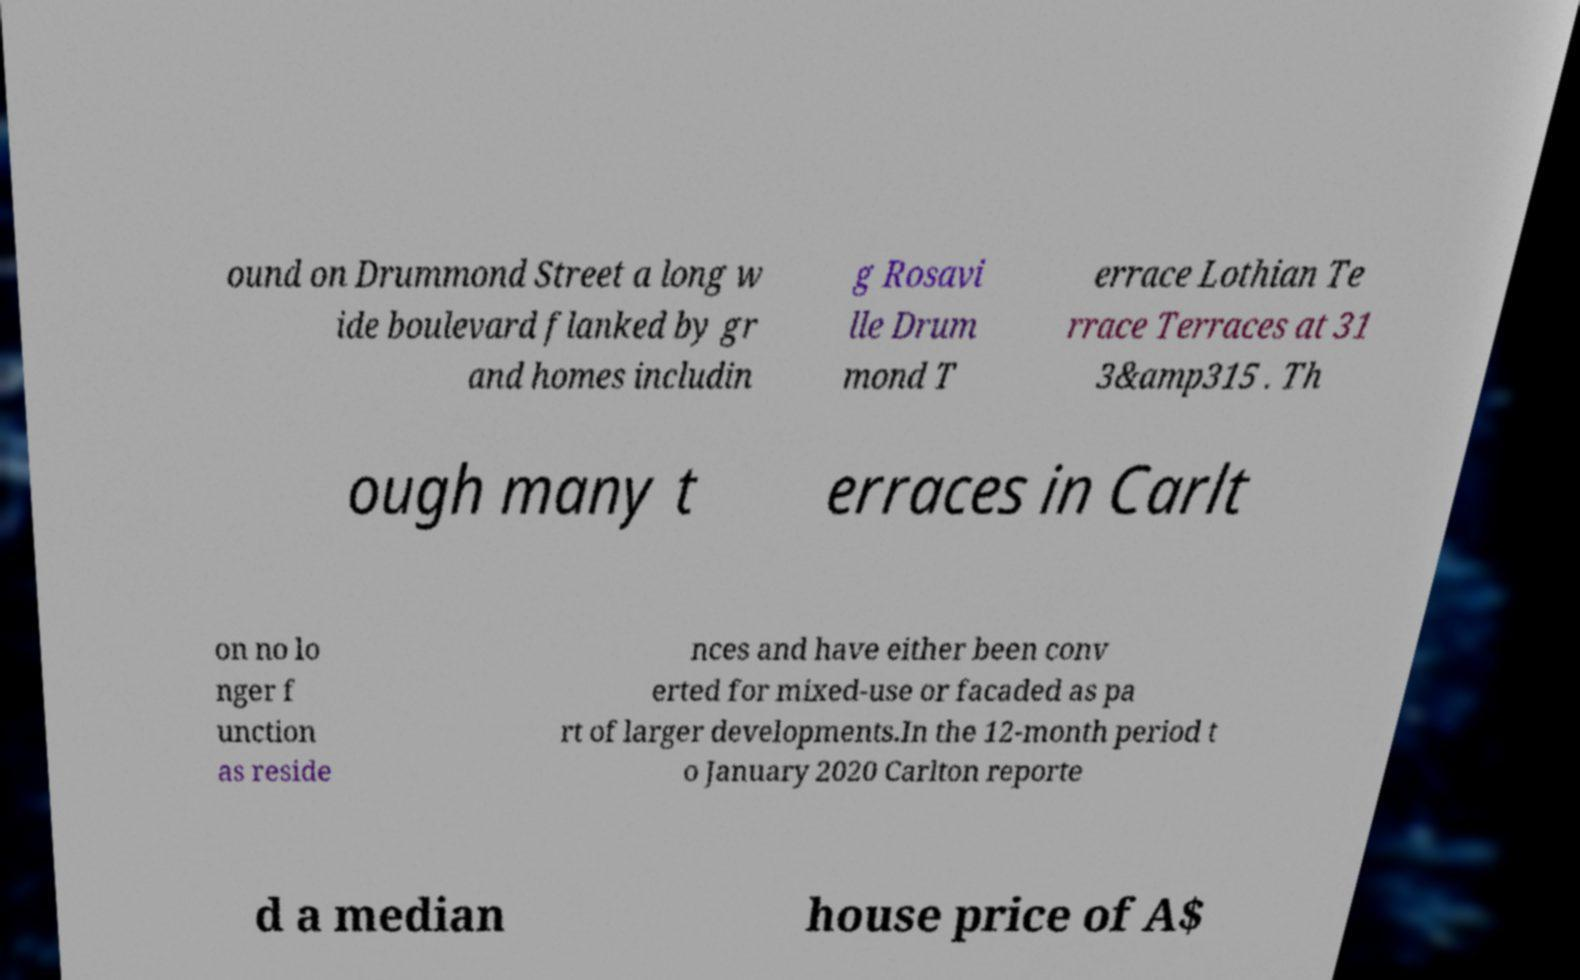Can you read and provide the text displayed in the image?This photo seems to have some interesting text. Can you extract and type it out for me? ound on Drummond Street a long w ide boulevard flanked by gr and homes includin g Rosavi lle Drum mond T errace Lothian Te rrace Terraces at 31 3&amp315 . Th ough many t erraces in Carlt on no lo nger f unction as reside nces and have either been conv erted for mixed-use or facaded as pa rt of larger developments.In the 12-month period t o January 2020 Carlton reporte d a median house price of A$ 